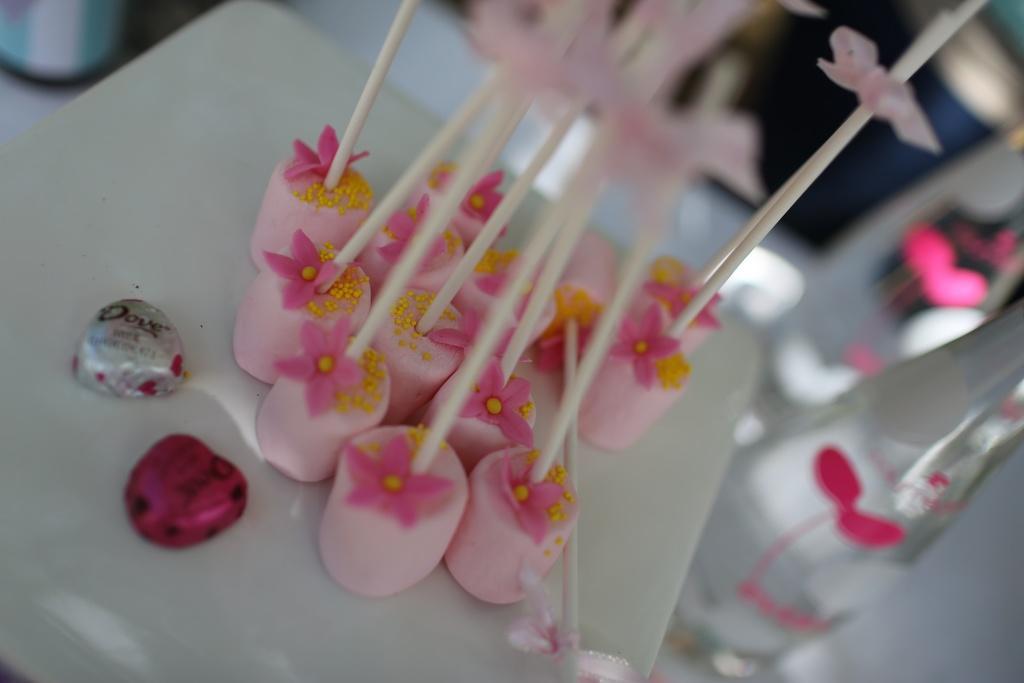How would you summarize this image in a sentence or two? On this white surface we can see candies. Background it is blur. Here we can see bottles. 